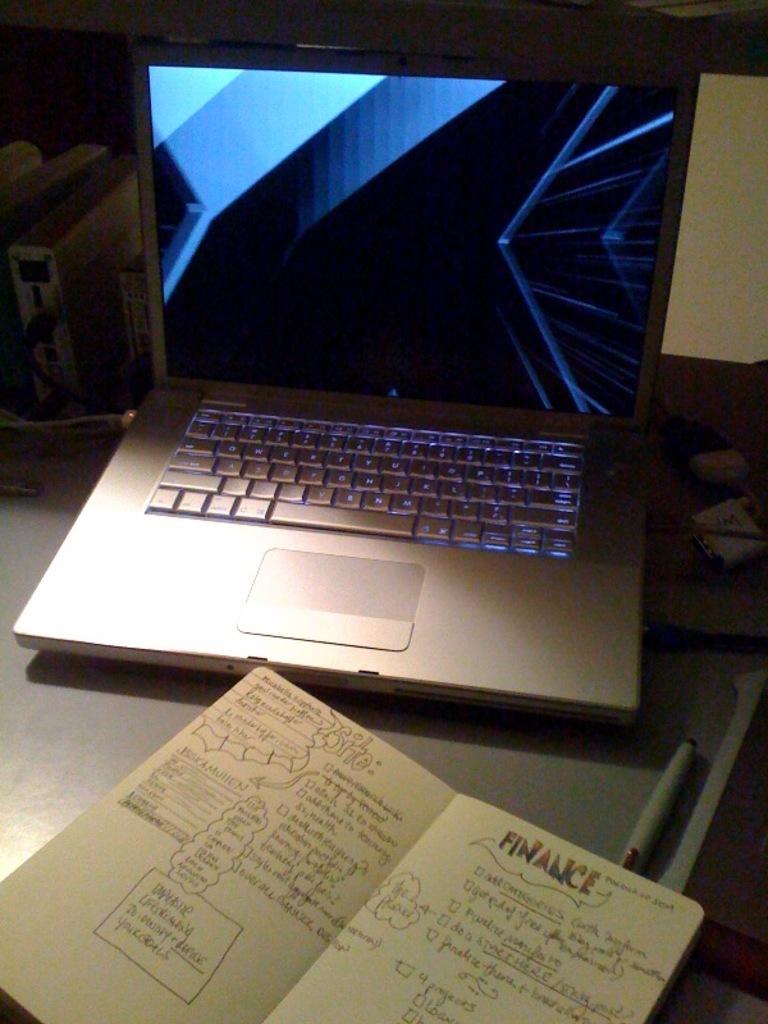What is the word in color in the book on the right page?
Your response must be concise. Finance. 